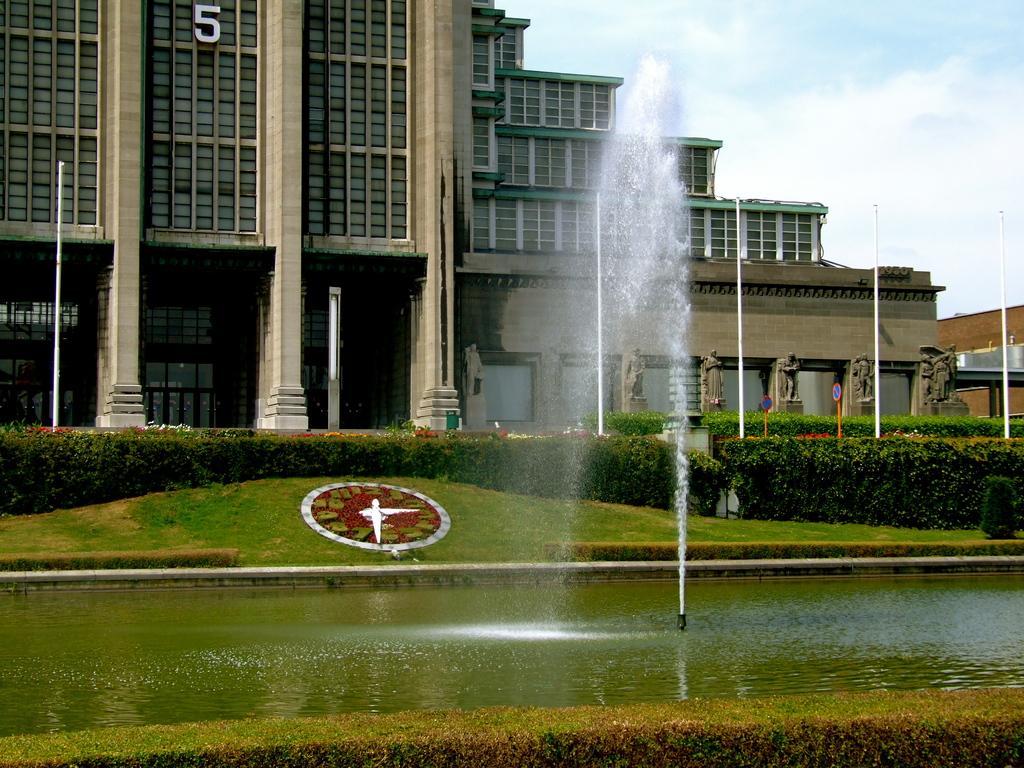Describe this image in one or two sentences. In this image we can see buildings, poles, pillars, sky with clouds, statues, bushes, decor, water, fountain and ground. 